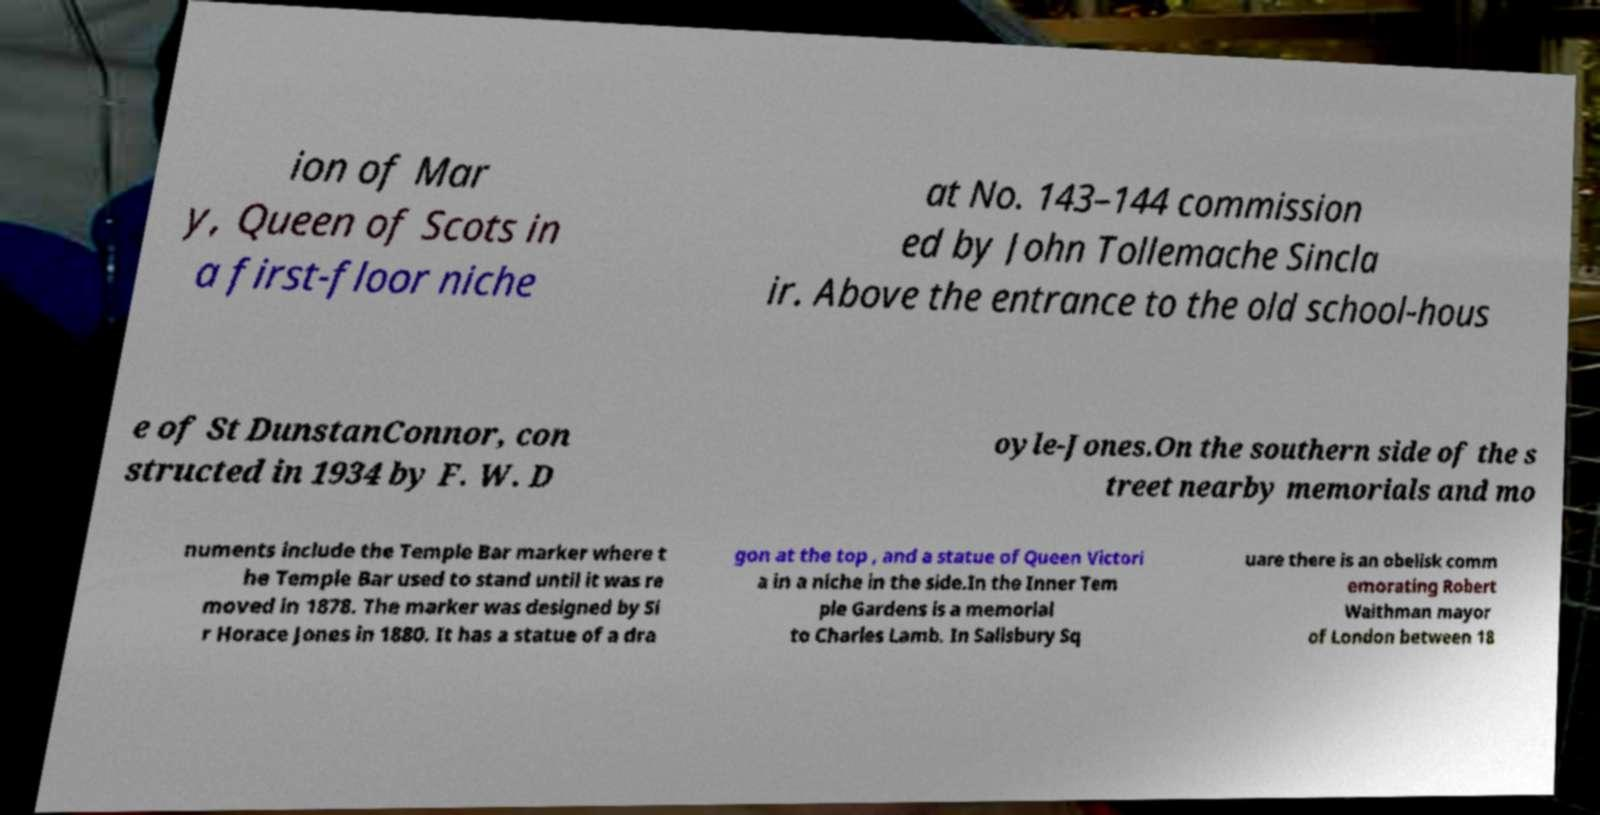There's text embedded in this image that I need extracted. Can you transcribe it verbatim? ion of Mar y, Queen of Scots in a first-floor niche at No. 143–144 commission ed by John Tollemache Sincla ir. Above the entrance to the old school-hous e of St DunstanConnor, con structed in 1934 by F. W. D oyle-Jones.On the southern side of the s treet nearby memorials and mo numents include the Temple Bar marker where t he Temple Bar used to stand until it was re moved in 1878. The marker was designed by Si r Horace Jones in 1880. It has a statue of a dra gon at the top , and a statue of Queen Victori a in a niche in the side.In the Inner Tem ple Gardens is a memorial to Charles Lamb. In Salisbury Sq uare there is an obelisk comm emorating Robert Waithman mayor of London between 18 